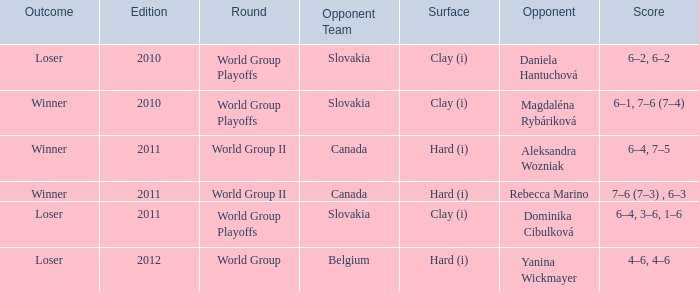Parse the full table. {'header': ['Outcome', 'Edition', 'Round', 'Opponent Team', 'Surface', 'Opponent', 'Score'], 'rows': [['Loser', '2010', 'World Group Playoffs', 'Slovakia', 'Clay (i)', 'Daniela Hantuchová', '6–2, 6–2'], ['Winner', '2010', 'World Group Playoffs', 'Slovakia', 'Clay (i)', 'Magdaléna Rybáriková', '6–1, 7–6 (7–4)'], ['Winner', '2011', 'World Group II', 'Canada', 'Hard (i)', 'Aleksandra Wozniak', '6–4, 7–5'], ['Winner', '2011', 'World Group II', 'Canada', 'Hard (i)', 'Rebecca Marino', '7–6 (7–3) , 6–3'], ['Loser', '2011', 'World Group Playoffs', 'Slovakia', 'Clay (i)', 'Dominika Cibulková', '6–4, 3–6, 1–6'], ['Loser', '2012', 'World Group', 'Belgium', 'Hard (i)', 'Yanina Wickmayer', '4–6, 4–6']]} What is the count of outcomes with the opponent being aleksandra wozniak? 1.0. 